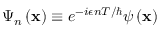<formula> <loc_0><loc_0><loc_500><loc_500>\Psi _ { n } \left ( x \right ) \equiv e ^ { - i \epsilon n T / } \psi \left ( x \right )</formula> 